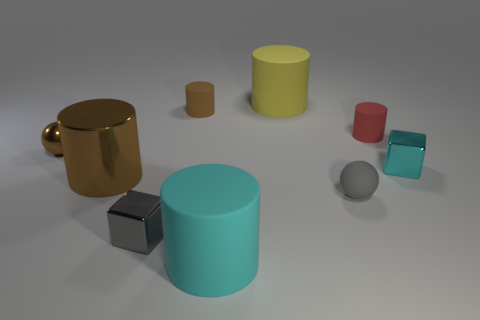What material is the object that is the same color as the matte sphere?
Offer a terse response. Metal. Is the color of the metal ball the same as the big metallic thing?
Offer a terse response. Yes. What is the material of the brown thing that is the same size as the yellow cylinder?
Ensure brevity in your answer.  Metal. Do the tiny cyan cube and the yellow object have the same material?
Provide a short and direct response. No. What number of other things are the same color as the metal cylinder?
Offer a terse response. 2. What number of rubber objects are either cylinders or small brown cylinders?
Your response must be concise. 4. Does the big matte object behind the brown metal sphere have the same color as the ball that is in front of the brown ball?
Keep it short and to the point. No. There is a yellow rubber thing that is the same shape as the large metal object; what is its size?
Offer a terse response. Large. Is the number of red rubber objects behind the gray block greater than the number of tiny red metallic cylinders?
Give a very brief answer. Yes. Does the tiny cube in front of the cyan cube have the same material as the small brown ball?
Make the answer very short. Yes. 